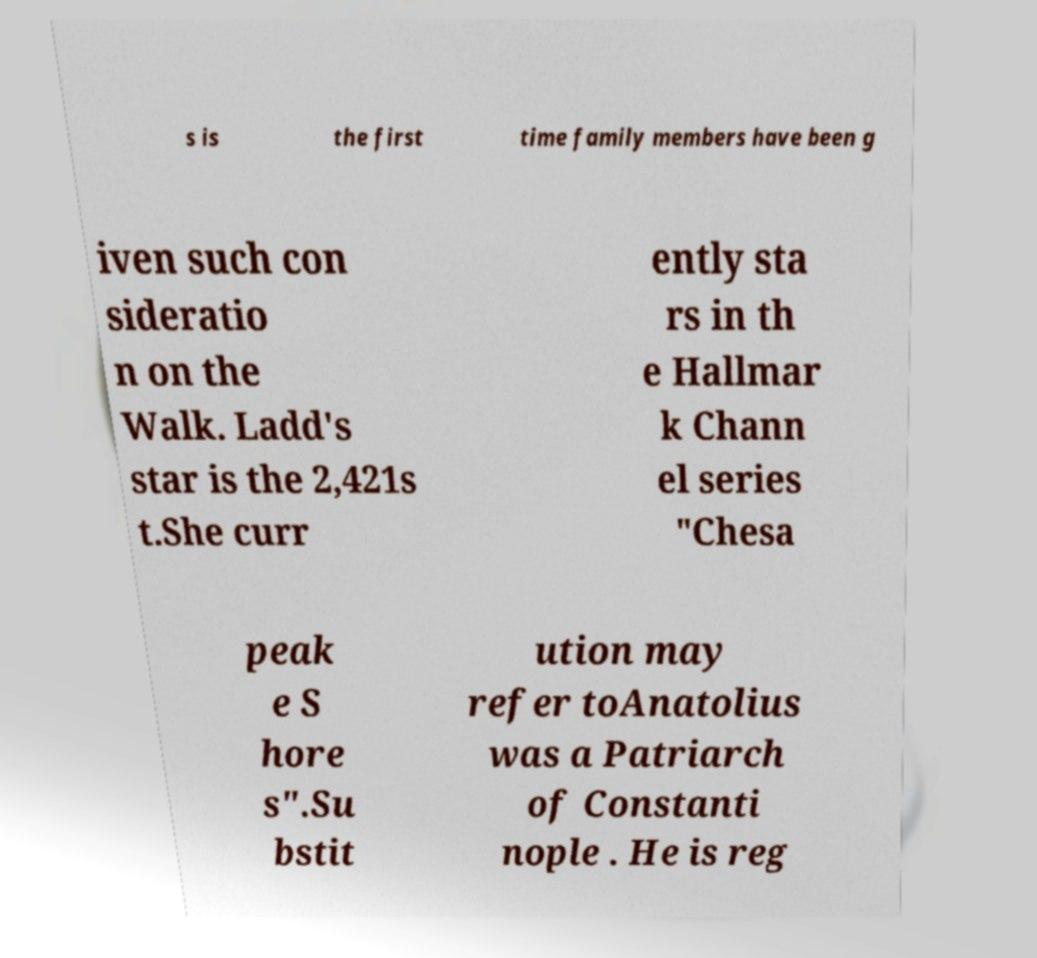Can you accurately transcribe the text from the provided image for me? s is the first time family members have been g iven such con sideratio n on the Walk. Ladd's star is the 2,421s t.She curr ently sta rs in th e Hallmar k Chann el series "Chesa peak e S hore s".Su bstit ution may refer toAnatolius was a Patriarch of Constanti nople . He is reg 